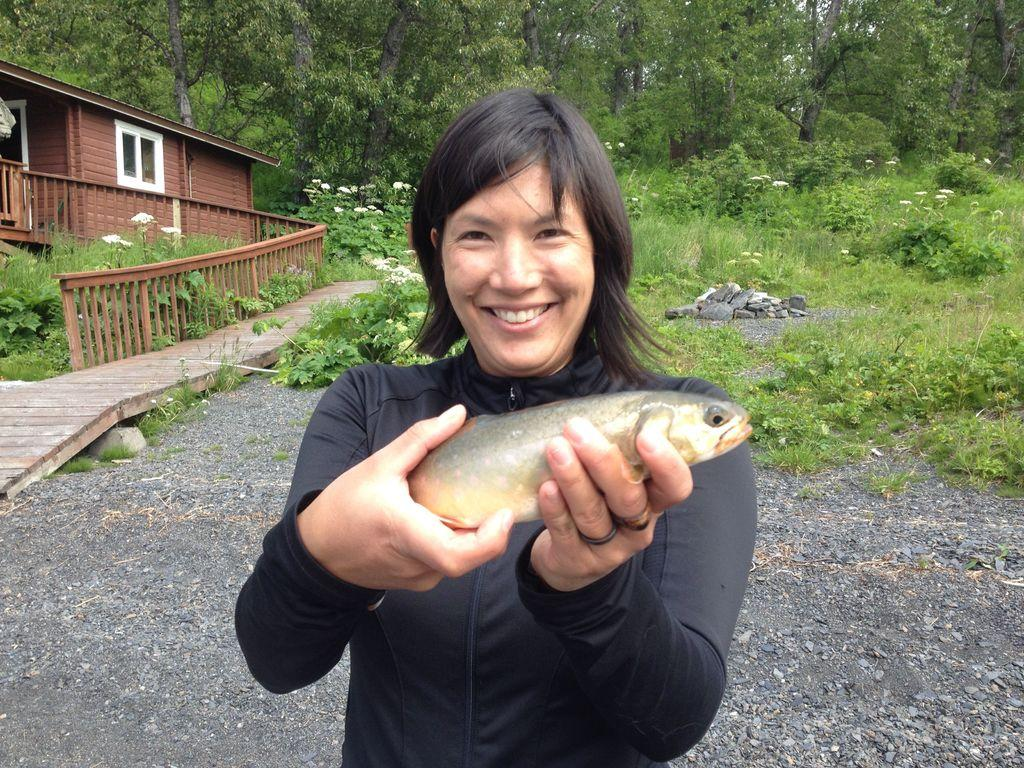Who is present in the image? There is a woman in the image. What is the woman doing in the image? The woman is smiling in the image. What is the woman holding in the image? The woman is holding a fish in the image. What can be seen in the background of the image? There are plants, flowers, grass, a house, a fence, stones, and trees in the background of the image. What type of plastic material can be seen in the image? There is no plastic material present in the image. 